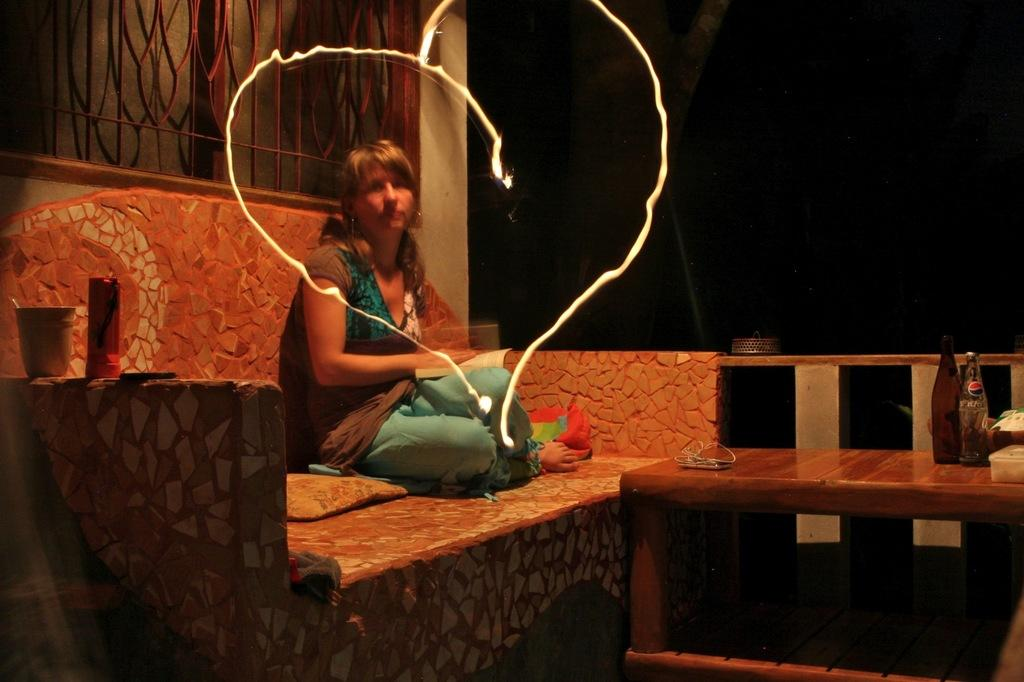What is the woman in the image doing? The woman is sitting in the image. What can be seen behind the woman? There is a window behind the woman. What objects are on the table on the right side of the image? There are bottles on the table on the right side of the image. How many girls are present in the image? There is no girl mentioned in the facts provided; only a woman is mentioned. What type of bedroom is shown in the image? There is no bedroom present in the image; it is not mentioned in the facts provided. 